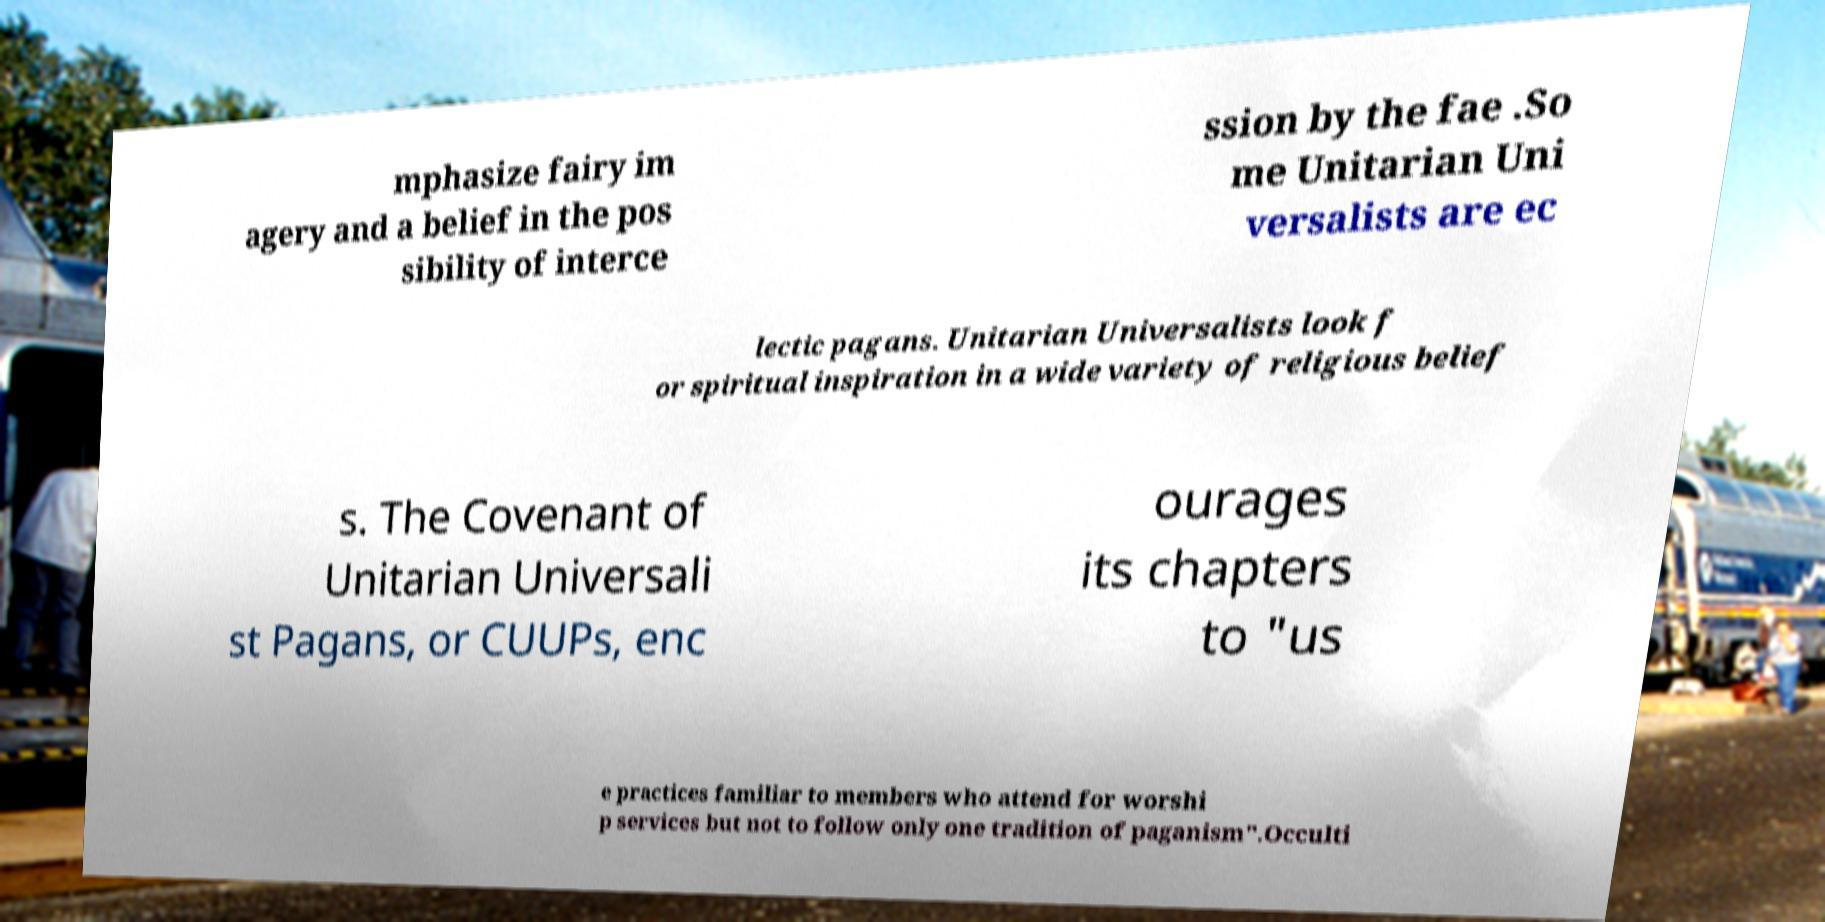For documentation purposes, I need the text within this image transcribed. Could you provide that? mphasize fairy im agery and a belief in the pos sibility of interce ssion by the fae .So me Unitarian Uni versalists are ec lectic pagans. Unitarian Universalists look f or spiritual inspiration in a wide variety of religious belief s. The Covenant of Unitarian Universali st Pagans, or CUUPs, enc ourages its chapters to "us e practices familiar to members who attend for worshi p services but not to follow only one tradition of paganism".Occulti 